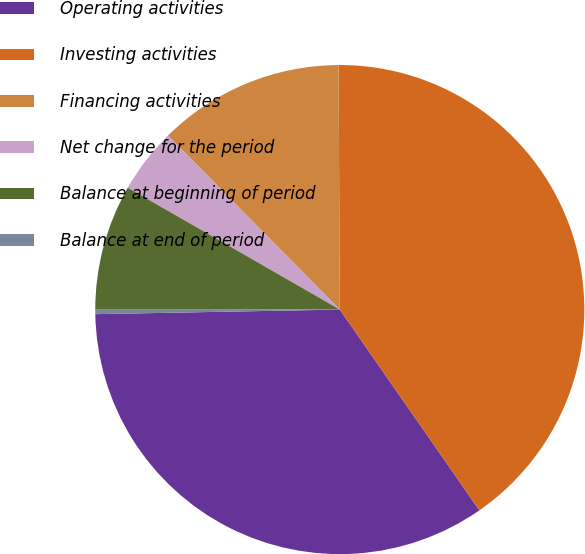Convert chart to OTSL. <chart><loc_0><loc_0><loc_500><loc_500><pie_chart><fcel>Operating activities<fcel>Investing activities<fcel>Financing activities<fcel>Net change for the period<fcel>Balance at beginning of period<fcel>Balance at end of period<nl><fcel>34.37%<fcel>40.41%<fcel>12.32%<fcel>4.3%<fcel>8.31%<fcel>0.29%<nl></chart> 